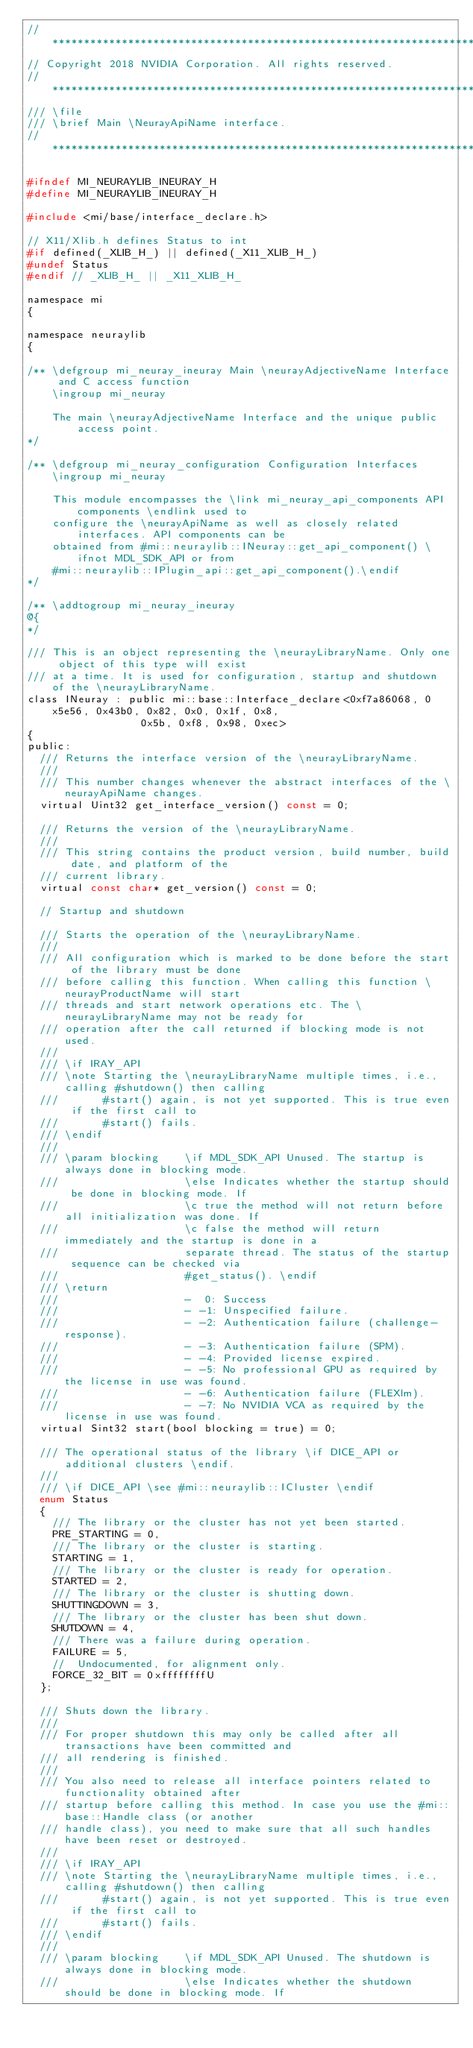Convert code to text. <code><loc_0><loc_0><loc_500><loc_500><_C_>//*****************************************************************************
// Copyright 2018 NVIDIA Corporation. All rights reserved.
//*****************************************************************************
/// \file
/// \brief Main \NeurayApiName interface.
//*****************************************************************************

#ifndef MI_NEURAYLIB_INEURAY_H
#define MI_NEURAYLIB_INEURAY_H

#include <mi/base/interface_declare.h>

// X11/Xlib.h defines Status to int
#if defined(_XLIB_H_) || defined(_X11_XLIB_H_)
#undef Status
#endif // _XLIB_H_ || _X11_XLIB_H_

namespace mi
{

namespace neuraylib
{

/** \defgroup mi_neuray_ineuray Main \neurayAdjectiveName Interface and C access function
    \ingroup mi_neuray

    The main \neurayAdjectiveName Interface and the unique public access point.
*/

/** \defgroup mi_neuray_configuration Configuration Interfaces
    \ingroup mi_neuray

    This module encompasses the \link mi_neuray_api_components API components \endlink used to
    configure the \neurayApiName as well as closely related interfaces. API components can be
    obtained from #mi::neuraylib::INeuray::get_api_component() \ifnot MDL_SDK_API or from
    #mi::neuraylib::IPlugin_api::get_api_component().\endif
*/

/** \addtogroup mi_neuray_ineuray
@{
*/

/// This is an object representing the \neurayLibraryName. Only one object of this type will exist
/// at a time. It is used for configuration, startup and shutdown of the \neurayLibraryName.
class INeuray : public mi::base::Interface_declare<0xf7a86068, 0x5e56, 0x43b0, 0x82, 0x0, 0x1f, 0x8,
                  0x5b, 0xf8, 0x98, 0xec>
{
public:
  /// Returns the interface version of the \neurayLibraryName.
  ///
  /// This number changes whenever the abstract interfaces of the \neurayApiName changes.
  virtual Uint32 get_interface_version() const = 0;

  /// Returns the version of the \neurayLibraryName.
  ///
  /// This string contains the product version, build number, build date, and platform of the
  /// current library.
  virtual const char* get_version() const = 0;

  // Startup and shutdown

  /// Starts the operation of the \neurayLibraryName.
  ///
  /// All configuration which is marked to be done before the start of the library must be done
  /// before calling this function. When calling this function \neurayProductName will start
  /// threads and start network operations etc. The \neurayLibraryName may not be ready for
  /// operation after the call returned if blocking mode is not used.
  ///
  /// \if IRAY_API
  /// \note Starting the \neurayLibraryName multiple times, i.e., calling #shutdown() then calling
  ///       #start() again, is not yet supported. This is true even if the first call to
  ///       #start() fails.
  /// \endif
  ///
  /// \param blocking    \if MDL_SDK_API Unused. The startup is always done in blocking mode.
  ///                    \else Indicates whether the startup should be done in blocking mode. If
  ///                    \c true the method will not return before all initialization was done. If
  ///                    \c false the method will return immediately and the startup is done in a
  ///                    separate thread. The status of the startup sequence can be checked via
  ///                    #get_status(). \endif
  /// \return
  ///                    -  0: Success
  ///                    - -1: Unspecified failure.
  ///                    - -2: Authentication failure (challenge-response).
  ///                    - -3: Authentication failure (SPM).
  ///                    - -4: Provided license expired.
  ///                    - -5: No professional GPU as required by the license in use was found.
  ///                    - -6: Authentication failure (FLEXlm).
  ///                    - -7: No NVIDIA VCA as required by the license in use was found.
  virtual Sint32 start(bool blocking = true) = 0;

  /// The operational status of the library \if DICE_API or additional clusters \endif.
  ///
  /// \if DICE_API \see #mi::neuraylib::ICluster \endif
  enum Status
  {
    /// The library or the cluster has not yet been started.
    PRE_STARTING = 0,
    /// The library or the cluster is starting.
    STARTING = 1,
    /// The library or the cluster is ready for operation.
    STARTED = 2,
    /// The library or the cluster is shutting down.
    SHUTTINGDOWN = 3,
    /// The library or the cluster has been shut down.
    SHUTDOWN = 4,
    /// There was a failure during operation.
    FAILURE = 5,
    //  Undocumented, for alignment only.
    FORCE_32_BIT = 0xffffffffU
  };

  /// Shuts down the library.
  ///
  /// For proper shutdown this may only be called after all transactions have been committed and
  /// all rendering is finished.
  ///
  /// You also need to release all interface pointers related to functionality obtained after
  /// startup before calling this method. In case you use the #mi::base::Handle class (or another
  /// handle class), you need to make sure that all such handles have been reset or destroyed.
  ///
  /// \if IRAY_API
  /// \note Starting the \neurayLibraryName multiple times, i.e., calling #shutdown() then calling
  ///       #start() again, is not yet supported. This is true even if the first call to
  ///       #start() fails.
  /// \endif
  ///
  /// \param blocking    \if MDL_SDK_API Unused. The shutdown is always done in blocking mode.
  ///                    \else Indicates whether the shutdown should be done in blocking mode. If</code> 